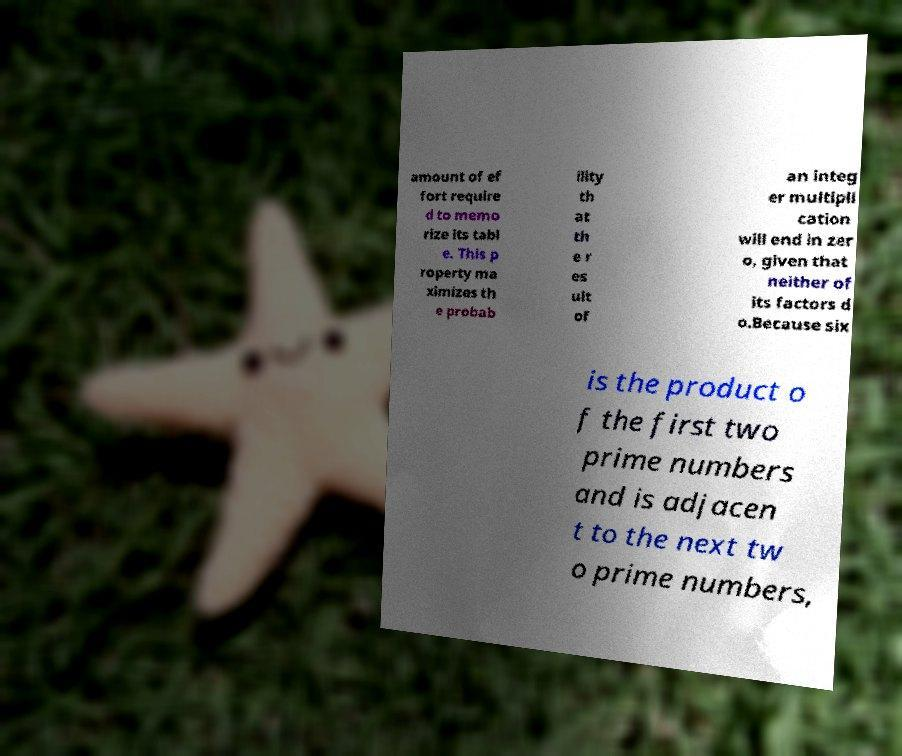For documentation purposes, I need the text within this image transcribed. Could you provide that? amount of ef fort require d to memo rize its tabl e. This p roperty ma ximizes th e probab ility th at th e r es ult of an integ er multipli cation will end in zer o, given that neither of its factors d o.Because six is the product o f the first two prime numbers and is adjacen t to the next tw o prime numbers, 